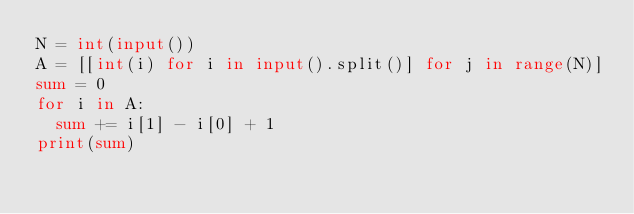Convert code to text. <code><loc_0><loc_0><loc_500><loc_500><_Python_>N = int(input())
A = [[int(i) for i in input().split()] for j in range(N)]
sum = 0
for i in A:
  sum += i[1] - i[0] + 1
print(sum)</code> 